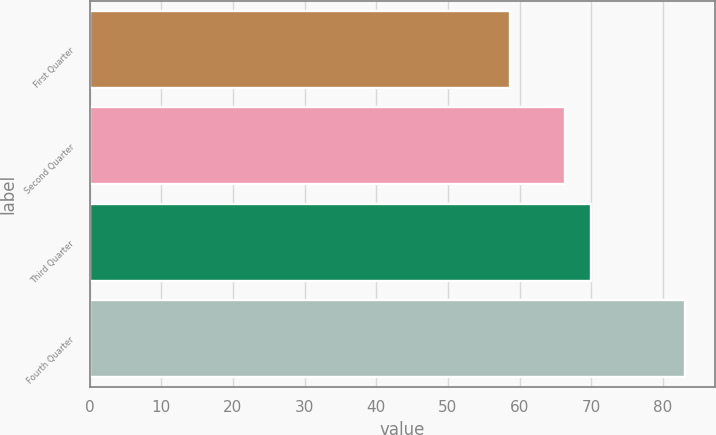Convert chart. <chart><loc_0><loc_0><loc_500><loc_500><bar_chart><fcel>First Quarter<fcel>Second Quarter<fcel>Third Quarter<fcel>Fourth Quarter<nl><fcel>58.69<fcel>66.36<fcel>70<fcel>83.09<nl></chart> 